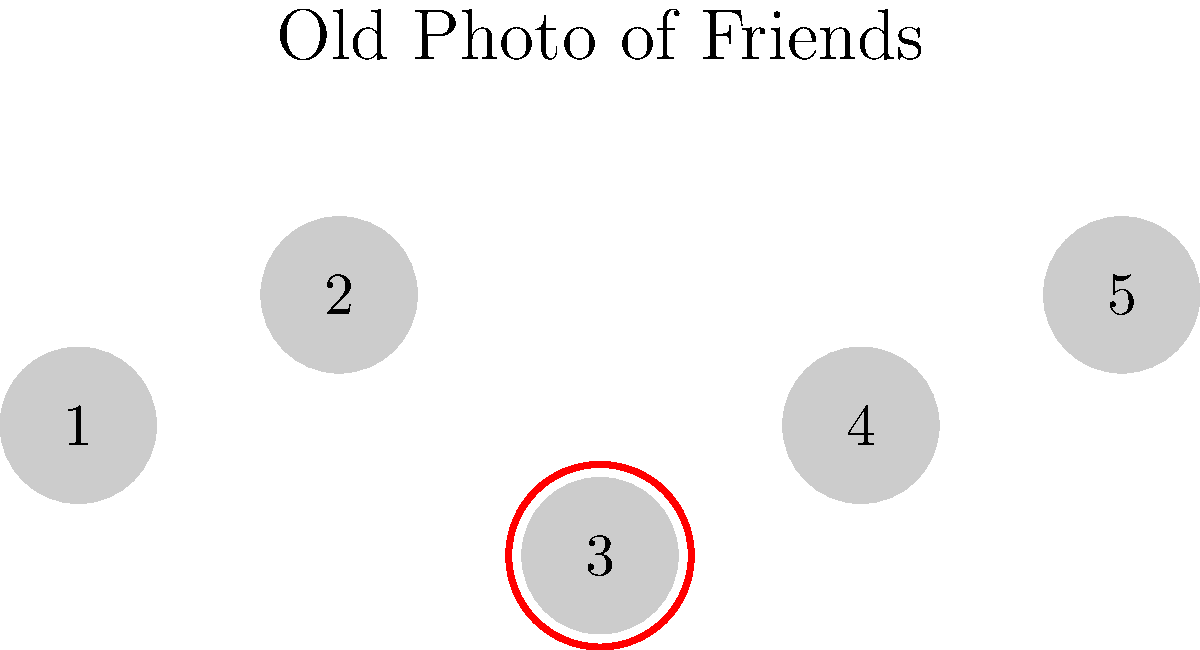In this old group photo of friends, which numbered figure represents Marilyn based on your childhood memories? To identify Marilyn in this old group photo, we need to follow these steps:

1. Examine the photo carefully, noting that there are 5 figures labeled from 1 to 5.
2. Recall your childhood memories of Marilyn's appearance and mannerisms.
3. Look for distinguishing features that match your recollection of Marilyn, such as her hairstyle, posture, or relative position in group photos.
4. Notice that figure 3 is highlighted with a red circle, which is a visual cue suggesting this might be Marilyn.
5. Compare this highlighted figure with your memories of Marilyn from your childhood.
6. Consider that as a childhood friend who lost touch years ago, your memory might not be perfect, but certain characteristics should still stand out.
7. Based on the visual cue and your recollection, conclude that figure 3 is most likely to be Marilyn.
Answer: 3 